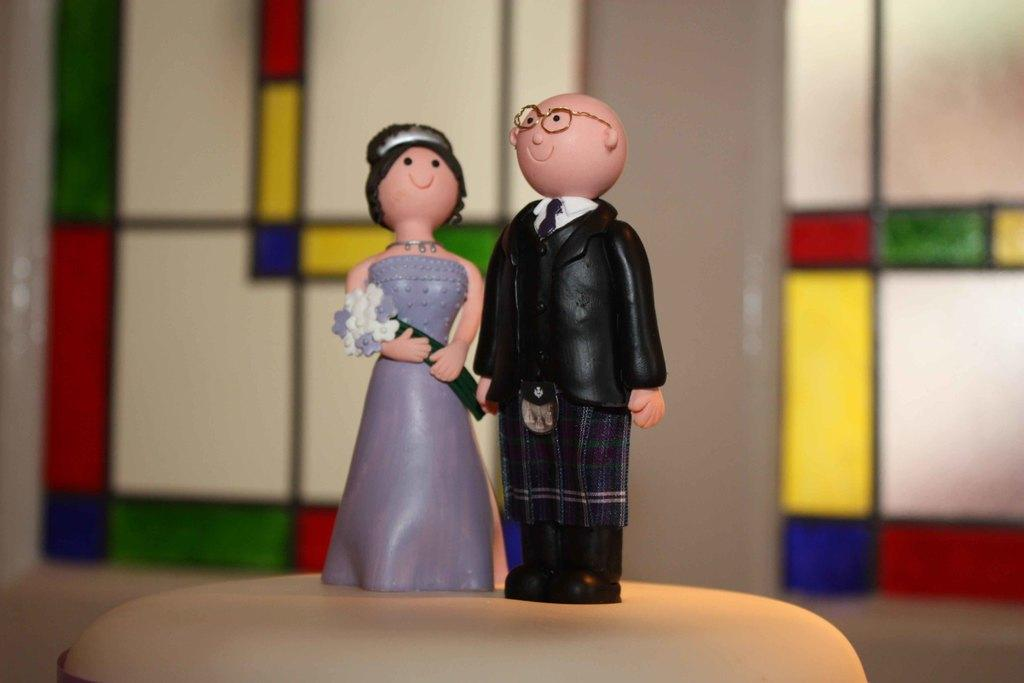What types of toys are in the image? There are toys of a man and a woman in the image. What is the toy of the woman holding? The toy of the woman is holding a bouquet. What can be seen in the background of the image? There is a wall in the background of the image. What type of humor does the governor display in the image? There is no governor present in the image, and therefore no humor can be attributed to a governor. 